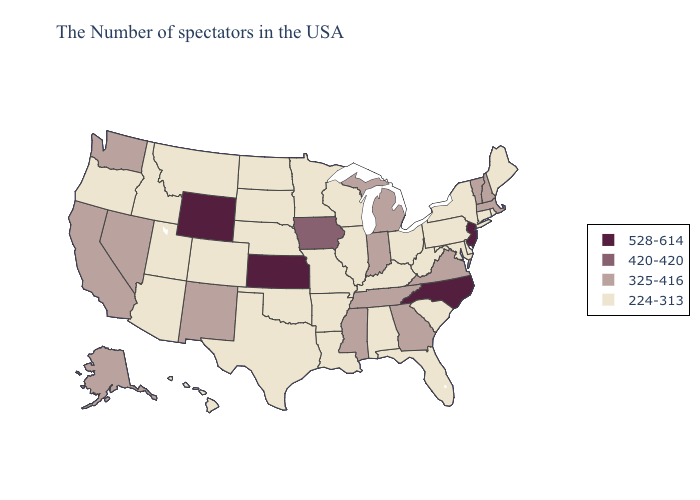What is the highest value in the South ?
Give a very brief answer. 528-614. What is the value of Tennessee?
Quick response, please. 325-416. Name the states that have a value in the range 528-614?
Concise answer only. New Jersey, North Carolina, Kansas, Wyoming. Does Florida have the lowest value in the South?
Keep it brief. Yes. Name the states that have a value in the range 528-614?
Write a very short answer. New Jersey, North Carolina, Kansas, Wyoming. Does North Dakota have the lowest value in the USA?
Be succinct. Yes. What is the lowest value in the Northeast?
Short answer required. 224-313. Name the states that have a value in the range 325-416?
Answer briefly. Massachusetts, New Hampshire, Vermont, Virginia, Georgia, Michigan, Indiana, Tennessee, Mississippi, New Mexico, Nevada, California, Washington, Alaska. Which states have the lowest value in the MidWest?
Write a very short answer. Ohio, Wisconsin, Illinois, Missouri, Minnesota, Nebraska, South Dakota, North Dakota. Among the states that border West Virginia , which have the lowest value?
Keep it brief. Maryland, Pennsylvania, Ohio, Kentucky. What is the lowest value in states that border Maine?
Keep it brief. 325-416. Which states hav the highest value in the MidWest?
Write a very short answer. Kansas. Does Pennsylvania have a lower value than Iowa?
Keep it brief. Yes. What is the highest value in states that border Indiana?
Answer briefly. 325-416. Does Rhode Island have the lowest value in the Northeast?
Short answer required. Yes. 